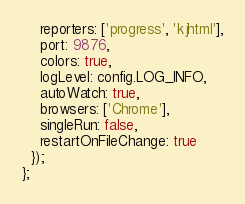<code> <loc_0><loc_0><loc_500><loc_500><_JavaScript_>    reporters: ['progress', 'kjhtml'],
    port: 9876,
    colors: true,
    logLevel: config.LOG_INFO,
    autoWatch: true,
    browsers: ['Chrome'],
    singleRun: false,
    restartOnFileChange: true
  });
};
</code> 